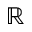Convert formula to latex. <formula><loc_0><loc_0><loc_500><loc_500>\mathbb { R }</formula> 